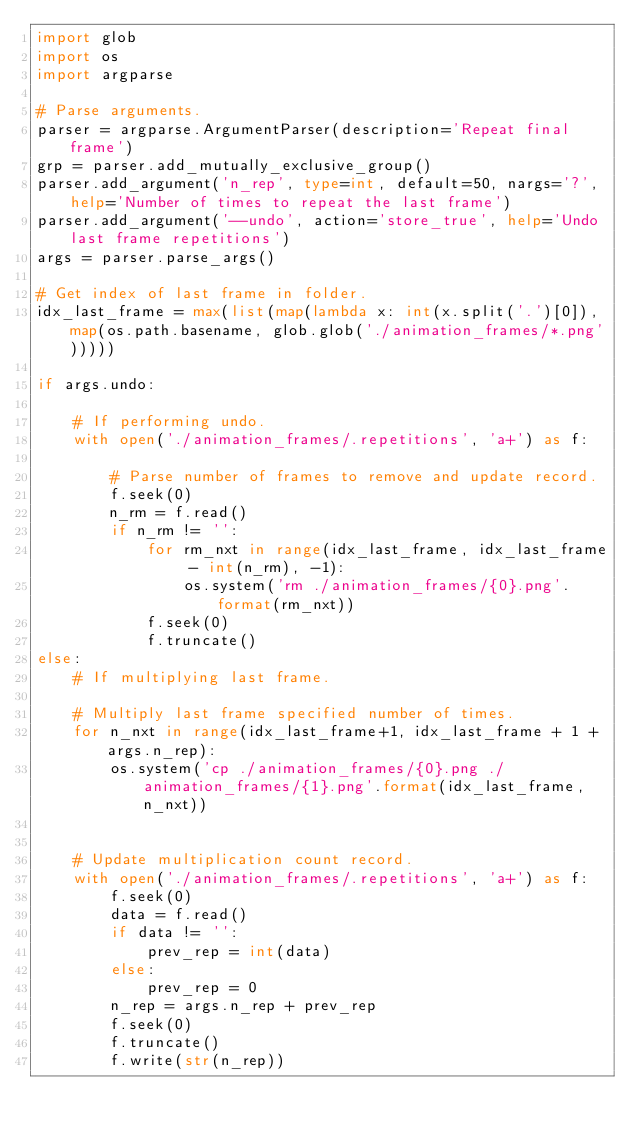Convert code to text. <code><loc_0><loc_0><loc_500><loc_500><_Python_>import glob
import os
import argparse

# Parse arguments.
parser = argparse.ArgumentParser(description='Repeat final frame')
grp = parser.add_mutually_exclusive_group()
parser.add_argument('n_rep', type=int, default=50, nargs='?', help='Number of times to repeat the last frame')
parser.add_argument('--undo', action='store_true', help='Undo last frame repetitions')
args = parser.parse_args()

# Get index of last frame in folder.
idx_last_frame = max(list(map(lambda x: int(x.split('.')[0]), map(os.path.basename, glob.glob('./animation_frames/*.png')))))

if args.undo:
    
    # If performing undo.
    with open('./animation_frames/.repetitions', 'a+') as f:

        # Parse number of frames to remove and update record.
        f.seek(0)
        n_rm = f.read()
        if n_rm != '':
            for rm_nxt in range(idx_last_frame, idx_last_frame - int(n_rm), -1):
                os.system('rm ./animation_frames/{0}.png'.format(rm_nxt))
            f.seek(0)
            f.truncate()
else:
    # If multiplying last frame.

    # Multiply last frame specified number of times.
    for n_nxt in range(idx_last_frame+1, idx_last_frame + 1 + args.n_rep):
        os.system('cp ./animation_frames/{0}.png ./animation_frames/{1}.png'.format(idx_last_frame, n_nxt))


    # Update multiplication count record.
    with open('./animation_frames/.repetitions', 'a+') as f:
        f.seek(0)
        data = f.read()
        if data != '':
            prev_rep = int(data)
        else:
            prev_rep = 0
        n_rep = args.n_rep + prev_rep
        f.seek(0)
        f.truncate()
        f.write(str(n_rep))


</code> 